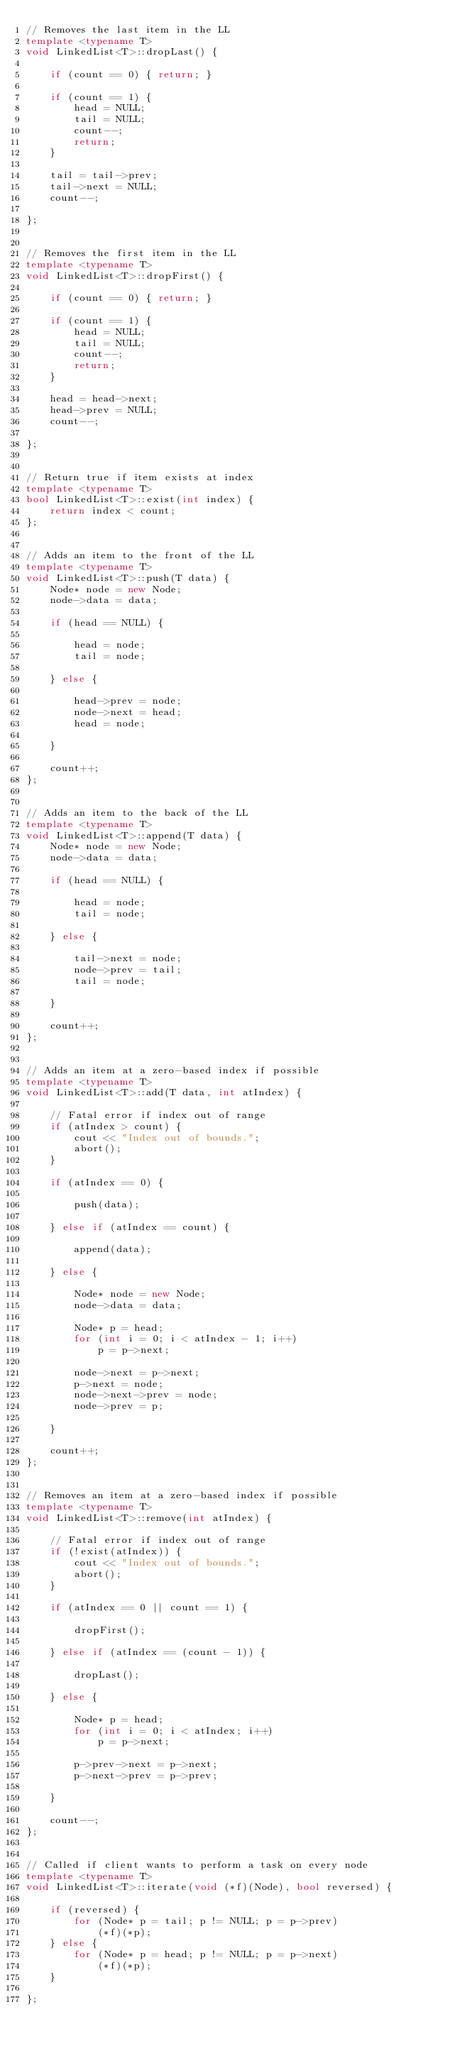Convert code to text. <code><loc_0><loc_0><loc_500><loc_500><_C++_>// Removes the last item in the LL
template <typename T>
void LinkedList<T>::dropLast() {
    
    if (count == 0) { return; }
    
    if (count == 1) {
        head = NULL;
        tail = NULL;
        count--;
        return;
    }
    
    tail = tail->prev;
    tail->next = NULL;
    count--;
    
};


// Removes the first item in the LL
template <typename T>
void LinkedList<T>::dropFirst() {
    
    if (count == 0) { return; }
    
    if (count == 1) {
        head = NULL;
        tail = NULL;
        count--;
        return;
    }
    
    head = head->next;
    head->prev = NULL;
    count--;
    
};


// Return true if item exists at index
template <typename T>
bool LinkedList<T>::exist(int index) {
    return index < count;
};


// Adds an item to the front of the LL
template <typename T>
void LinkedList<T>::push(T data) {
    Node* node = new Node;
    node->data = data;

    if (head == NULL) {
        
        head = node;
        tail = node;
        
    } else {
        
        head->prev = node;
        node->next = head;
        head = node;
        
    }
    
    count++;
};


// Adds an item to the back of the LL
template <typename T>
void LinkedList<T>::append(T data) {
    Node* node = new Node;
    node->data = data;

    if (head == NULL) {
        
        head = node;
        tail = node;
        
    } else {
        
        tail->next = node;
        node->prev = tail;
        tail = node;
        
    }
    
    count++;
};


// Adds an item at a zero-based index if possible
template <typename T>
void LinkedList<T>::add(T data, int atIndex) {
    
    // Fatal error if index out of range
    if (atIndex > count) {
        cout << "Index out of bounds.";
        abort();
    }
    
    if (atIndex == 0) {

        push(data);
        
    } else if (atIndex == count) {
        
        append(data);
        
    } else {
    
        Node* node = new Node;
        node->data = data;
        
        Node* p = head;
        for (int i = 0; i < atIndex - 1; i++) 
            p = p->next;

        node->next = p->next;
        p->next = node;
        node->next->prev = node;
        node->prev = p;
        
    }
    
    count++;
};


// Removes an item at a zero-based index if possible
template <typename T>
void LinkedList<T>::remove(int atIndex) {
    
    // Fatal error if index out of range
    if (!exist(atIndex)) {
        cout << "Index out of bounds.";
        abort();
    }
    
    if (atIndex == 0 || count == 1) {

        dropFirst();
        
    } else if (atIndex == (count - 1)) {
        
        dropLast();
        
    } else {
    
        Node* p = head;
        for (int i = 0; i < atIndex; i++)
            p = p->next;

        p->prev->next = p->next;
        p->next->prev = p->prev;
        
    }
    
    count--;
};


// Called if client wants to perform a task on every node
template <typename T>
void LinkedList<T>::iterate(void (*f)(Node), bool reversed) {

    if (reversed) {
        for (Node* p = tail; p != NULL; p = p->prev)
            (*f)(*p);
    } else {
        for (Node* p = head; p != NULL; p = p->next)
            (*f)(*p);
    }
    
};
</code> 